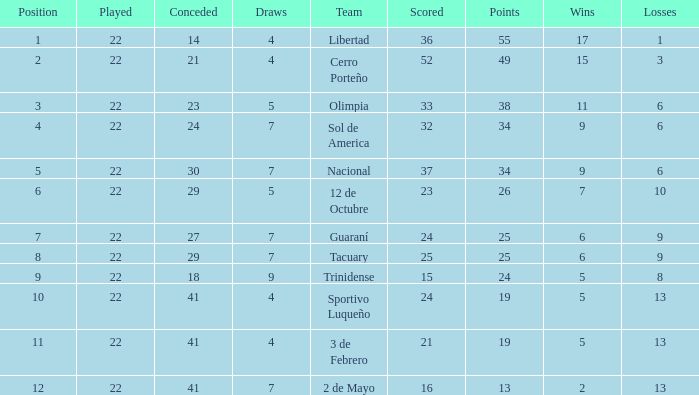What is the fewest wins that has fewer than 23 goals scored, team of 2 de Mayo, and fewer than 7 draws? None. Would you be able to parse every entry in this table? {'header': ['Position', 'Played', 'Conceded', 'Draws', 'Team', 'Scored', 'Points', 'Wins', 'Losses'], 'rows': [['1', '22', '14', '4', 'Libertad', '36', '55', '17', '1'], ['2', '22', '21', '4', 'Cerro Porteño', '52', '49', '15', '3'], ['3', '22', '23', '5', 'Olimpia', '33', '38', '11', '6'], ['4', '22', '24', '7', 'Sol de America', '32', '34', '9', '6'], ['5', '22', '30', '7', 'Nacional', '37', '34', '9', '6'], ['6', '22', '29', '5', '12 de Octubre', '23', '26', '7', '10'], ['7', '22', '27', '7', 'Guaraní', '24', '25', '6', '9'], ['8', '22', '29', '7', 'Tacuary', '25', '25', '6', '9'], ['9', '22', '18', '9', 'Trinidense', '15', '24', '5', '8'], ['10', '22', '41', '4', 'Sportivo Luqueño', '24', '19', '5', '13'], ['11', '22', '41', '4', '3 de Febrero', '21', '19', '5', '13'], ['12', '22', '41', '7', '2 de Mayo', '16', '13', '2', '13']]} 